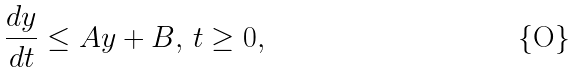<formula> <loc_0><loc_0><loc_500><loc_500>\frac { d y } { d t } \leq A y + B , \, t \geq 0 ,</formula> 